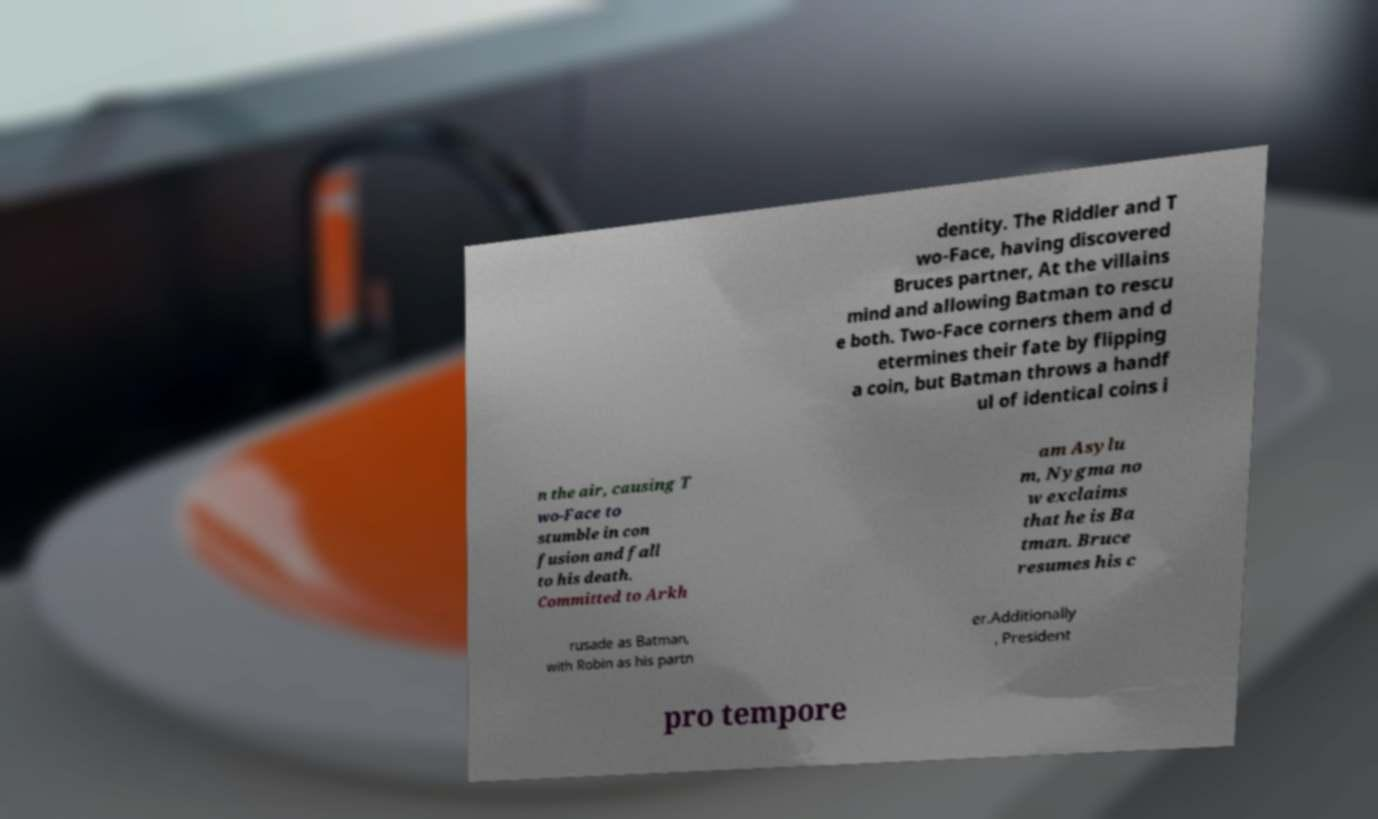There's text embedded in this image that I need extracted. Can you transcribe it verbatim? dentity. The Riddler and T wo-Face, having discovered Bruces partner, At the villains mind and allowing Batman to rescu e both. Two-Face corners them and d etermines their fate by flipping a coin, but Batman throws a handf ul of identical coins i n the air, causing T wo-Face to stumble in con fusion and fall to his death. Committed to Arkh am Asylu m, Nygma no w exclaims that he is Ba tman. Bruce resumes his c rusade as Batman, with Robin as his partn er.Additionally , President pro tempore 